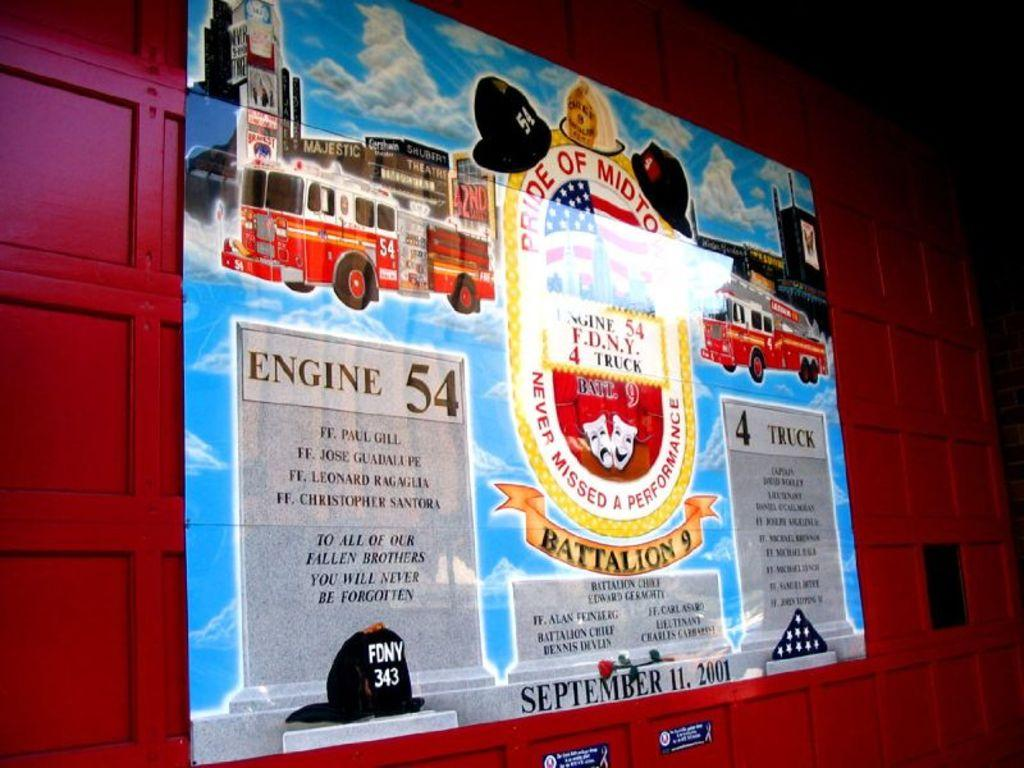What is on the wall in the image? There is a poster on the wall in the image. What is the rhythm of the nation depicted in the poster? There is no nation or rhythm depicted in the poster, as it only shows a poster on the wall. 